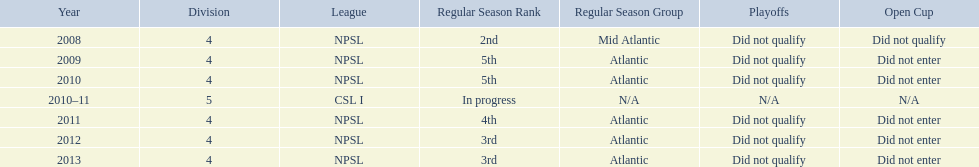What are the leagues? NPSL, NPSL, NPSL, CSL I, NPSL, NPSL, NPSL. Of these, what league is not npsl? CSL I. 